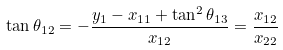<formula> <loc_0><loc_0><loc_500><loc_500>\tan \theta _ { 1 2 } = - \frac { y _ { 1 } - x _ { 1 1 } + \tan ^ { 2 } \theta _ { 1 3 } } { x _ { 1 2 } } = \frac { x _ { 1 2 } } { x _ { 2 2 } }</formula> 